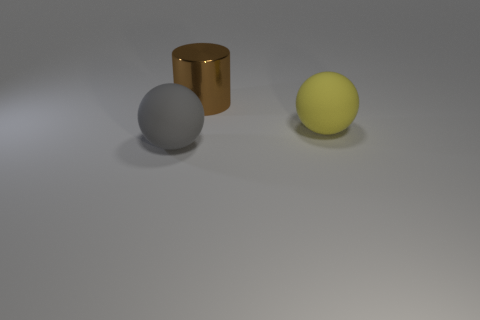Is there anything else that is the same material as the big cylinder?
Your answer should be very brief. No. What shape is the large brown metallic object that is to the right of the big matte ball to the left of the brown cylinder?
Provide a short and direct response. Cylinder. How many big things are blue rubber spheres or yellow balls?
Provide a succinct answer. 1. What number of red things have the same shape as the yellow object?
Your response must be concise. 0. There is a big gray rubber thing; is its shape the same as the big thing right of the big metal cylinder?
Give a very brief answer. Yes. There is a large shiny thing; what number of large yellow things are behind it?
Offer a terse response. 0. Is there a brown metal thing that has the same size as the gray rubber object?
Give a very brief answer. Yes. Is the shape of the matte object on the left side of the yellow matte sphere the same as  the yellow object?
Your response must be concise. Yes. The large metal cylinder has what color?
Offer a very short reply. Brown. Are any tiny gray things visible?
Provide a succinct answer. No. 